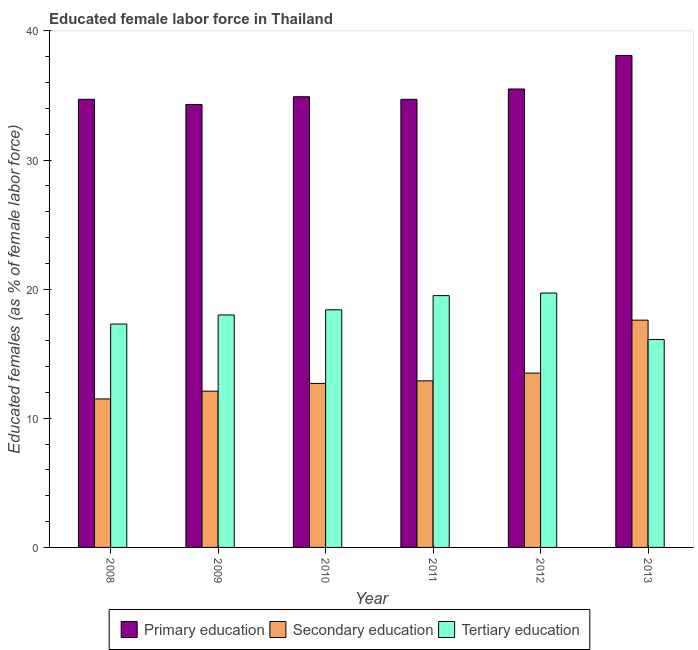Are the number of bars per tick equal to the number of legend labels?
Keep it short and to the point. Yes. Are the number of bars on each tick of the X-axis equal?
Provide a succinct answer. Yes. How many bars are there on the 1st tick from the right?
Your answer should be compact. 3. What is the percentage of female labor force who received primary education in 2011?
Your response must be concise. 34.7. Across all years, what is the maximum percentage of female labor force who received tertiary education?
Your response must be concise. 19.7. Across all years, what is the minimum percentage of female labor force who received secondary education?
Provide a succinct answer. 11.5. In which year was the percentage of female labor force who received tertiary education maximum?
Give a very brief answer. 2012. In which year was the percentage of female labor force who received secondary education minimum?
Ensure brevity in your answer.  2008. What is the total percentage of female labor force who received primary education in the graph?
Keep it short and to the point. 212.2. What is the difference between the percentage of female labor force who received tertiary education in 2010 and that in 2013?
Make the answer very short. 2.3. What is the difference between the percentage of female labor force who received secondary education in 2013 and the percentage of female labor force who received primary education in 2008?
Keep it short and to the point. 6.1. What is the average percentage of female labor force who received secondary education per year?
Ensure brevity in your answer.  13.38. In the year 2012, what is the difference between the percentage of female labor force who received tertiary education and percentage of female labor force who received secondary education?
Give a very brief answer. 0. What is the ratio of the percentage of female labor force who received secondary education in 2008 to that in 2010?
Make the answer very short. 0.91. What is the difference between the highest and the second highest percentage of female labor force who received secondary education?
Your answer should be compact. 4.1. What is the difference between the highest and the lowest percentage of female labor force who received primary education?
Ensure brevity in your answer.  3.8. In how many years, is the percentage of female labor force who received tertiary education greater than the average percentage of female labor force who received tertiary education taken over all years?
Make the answer very short. 3. What does the 3rd bar from the left in 2008 represents?
Provide a short and direct response. Tertiary education. Is it the case that in every year, the sum of the percentage of female labor force who received primary education and percentage of female labor force who received secondary education is greater than the percentage of female labor force who received tertiary education?
Provide a succinct answer. Yes. Does the graph contain any zero values?
Keep it short and to the point. No. Does the graph contain grids?
Ensure brevity in your answer.  No. How many legend labels are there?
Keep it short and to the point. 3. What is the title of the graph?
Ensure brevity in your answer.  Educated female labor force in Thailand. Does "Labor Market" appear as one of the legend labels in the graph?
Make the answer very short. No. What is the label or title of the X-axis?
Offer a terse response. Year. What is the label or title of the Y-axis?
Provide a short and direct response. Educated females (as % of female labor force). What is the Educated females (as % of female labor force) in Primary education in 2008?
Offer a terse response. 34.7. What is the Educated females (as % of female labor force) in Secondary education in 2008?
Your response must be concise. 11.5. What is the Educated females (as % of female labor force) in Tertiary education in 2008?
Offer a terse response. 17.3. What is the Educated females (as % of female labor force) in Primary education in 2009?
Your answer should be compact. 34.3. What is the Educated females (as % of female labor force) in Secondary education in 2009?
Provide a short and direct response. 12.1. What is the Educated females (as % of female labor force) in Primary education in 2010?
Make the answer very short. 34.9. What is the Educated females (as % of female labor force) of Secondary education in 2010?
Offer a very short reply. 12.7. What is the Educated females (as % of female labor force) in Tertiary education in 2010?
Offer a very short reply. 18.4. What is the Educated females (as % of female labor force) of Primary education in 2011?
Your answer should be compact. 34.7. What is the Educated females (as % of female labor force) of Secondary education in 2011?
Your answer should be compact. 12.9. What is the Educated females (as % of female labor force) of Tertiary education in 2011?
Offer a very short reply. 19.5. What is the Educated females (as % of female labor force) in Primary education in 2012?
Offer a very short reply. 35.5. What is the Educated females (as % of female labor force) of Tertiary education in 2012?
Your answer should be compact. 19.7. What is the Educated females (as % of female labor force) of Primary education in 2013?
Your response must be concise. 38.1. What is the Educated females (as % of female labor force) of Secondary education in 2013?
Offer a very short reply. 17.6. What is the Educated females (as % of female labor force) in Tertiary education in 2013?
Your answer should be compact. 16.1. Across all years, what is the maximum Educated females (as % of female labor force) of Primary education?
Give a very brief answer. 38.1. Across all years, what is the maximum Educated females (as % of female labor force) in Secondary education?
Provide a short and direct response. 17.6. Across all years, what is the maximum Educated females (as % of female labor force) of Tertiary education?
Offer a terse response. 19.7. Across all years, what is the minimum Educated females (as % of female labor force) of Primary education?
Provide a short and direct response. 34.3. Across all years, what is the minimum Educated females (as % of female labor force) of Secondary education?
Your answer should be compact. 11.5. Across all years, what is the minimum Educated females (as % of female labor force) in Tertiary education?
Your answer should be compact. 16.1. What is the total Educated females (as % of female labor force) in Primary education in the graph?
Your answer should be compact. 212.2. What is the total Educated females (as % of female labor force) of Secondary education in the graph?
Offer a very short reply. 80.3. What is the total Educated females (as % of female labor force) of Tertiary education in the graph?
Offer a very short reply. 109. What is the difference between the Educated females (as % of female labor force) in Secondary education in 2008 and that in 2009?
Offer a terse response. -0.6. What is the difference between the Educated females (as % of female labor force) in Primary education in 2008 and that in 2010?
Offer a very short reply. -0.2. What is the difference between the Educated females (as % of female labor force) of Tertiary education in 2008 and that in 2010?
Keep it short and to the point. -1.1. What is the difference between the Educated females (as % of female labor force) of Primary education in 2008 and that in 2011?
Provide a short and direct response. 0. What is the difference between the Educated females (as % of female labor force) of Tertiary education in 2008 and that in 2011?
Make the answer very short. -2.2. What is the difference between the Educated females (as % of female labor force) in Primary education in 2008 and that in 2012?
Provide a short and direct response. -0.8. What is the difference between the Educated females (as % of female labor force) of Tertiary education in 2008 and that in 2012?
Give a very brief answer. -2.4. What is the difference between the Educated females (as % of female labor force) of Primary education in 2008 and that in 2013?
Your answer should be compact. -3.4. What is the difference between the Educated females (as % of female labor force) of Secondary education in 2008 and that in 2013?
Give a very brief answer. -6.1. What is the difference between the Educated females (as % of female labor force) of Primary education in 2009 and that in 2010?
Make the answer very short. -0.6. What is the difference between the Educated females (as % of female labor force) in Primary education in 2009 and that in 2011?
Your answer should be very brief. -0.4. What is the difference between the Educated females (as % of female labor force) in Tertiary education in 2009 and that in 2011?
Provide a succinct answer. -1.5. What is the difference between the Educated females (as % of female labor force) of Primary education in 2009 and that in 2012?
Offer a very short reply. -1.2. What is the difference between the Educated females (as % of female labor force) in Secondary education in 2009 and that in 2012?
Your answer should be very brief. -1.4. What is the difference between the Educated females (as % of female labor force) in Primary education in 2009 and that in 2013?
Provide a short and direct response. -3.8. What is the difference between the Educated females (as % of female labor force) in Tertiary education in 2009 and that in 2013?
Your response must be concise. 1.9. What is the difference between the Educated females (as % of female labor force) of Primary education in 2010 and that in 2011?
Provide a succinct answer. 0.2. What is the difference between the Educated females (as % of female labor force) in Tertiary education in 2010 and that in 2012?
Keep it short and to the point. -1.3. What is the difference between the Educated females (as % of female labor force) of Secondary education in 2010 and that in 2013?
Your response must be concise. -4.9. What is the difference between the Educated females (as % of female labor force) in Tertiary education in 2010 and that in 2013?
Your response must be concise. 2.3. What is the difference between the Educated females (as % of female labor force) of Secondary education in 2011 and that in 2012?
Make the answer very short. -0.6. What is the difference between the Educated females (as % of female labor force) in Secondary education in 2011 and that in 2013?
Ensure brevity in your answer.  -4.7. What is the difference between the Educated females (as % of female labor force) in Secondary education in 2012 and that in 2013?
Provide a succinct answer. -4.1. What is the difference between the Educated females (as % of female labor force) in Tertiary education in 2012 and that in 2013?
Your answer should be very brief. 3.6. What is the difference between the Educated females (as % of female labor force) of Primary education in 2008 and the Educated females (as % of female labor force) of Secondary education in 2009?
Give a very brief answer. 22.6. What is the difference between the Educated females (as % of female labor force) in Secondary education in 2008 and the Educated females (as % of female labor force) in Tertiary education in 2009?
Provide a succinct answer. -6.5. What is the difference between the Educated females (as % of female labor force) of Primary education in 2008 and the Educated females (as % of female labor force) of Tertiary education in 2010?
Give a very brief answer. 16.3. What is the difference between the Educated females (as % of female labor force) in Secondary education in 2008 and the Educated females (as % of female labor force) in Tertiary education in 2010?
Your answer should be very brief. -6.9. What is the difference between the Educated females (as % of female labor force) of Primary education in 2008 and the Educated females (as % of female labor force) of Secondary education in 2011?
Keep it short and to the point. 21.8. What is the difference between the Educated females (as % of female labor force) of Primary education in 2008 and the Educated females (as % of female labor force) of Tertiary education in 2011?
Provide a succinct answer. 15.2. What is the difference between the Educated females (as % of female labor force) of Secondary education in 2008 and the Educated females (as % of female labor force) of Tertiary education in 2011?
Your answer should be very brief. -8. What is the difference between the Educated females (as % of female labor force) of Primary education in 2008 and the Educated females (as % of female labor force) of Secondary education in 2012?
Offer a very short reply. 21.2. What is the difference between the Educated females (as % of female labor force) of Primary education in 2008 and the Educated females (as % of female labor force) of Tertiary education in 2012?
Offer a terse response. 15. What is the difference between the Educated females (as % of female labor force) in Secondary education in 2008 and the Educated females (as % of female labor force) in Tertiary education in 2012?
Keep it short and to the point. -8.2. What is the difference between the Educated females (as % of female labor force) of Primary education in 2008 and the Educated females (as % of female labor force) of Tertiary education in 2013?
Give a very brief answer. 18.6. What is the difference between the Educated females (as % of female labor force) in Secondary education in 2008 and the Educated females (as % of female labor force) in Tertiary education in 2013?
Offer a very short reply. -4.6. What is the difference between the Educated females (as % of female labor force) in Primary education in 2009 and the Educated females (as % of female labor force) in Secondary education in 2010?
Offer a very short reply. 21.6. What is the difference between the Educated females (as % of female labor force) in Primary education in 2009 and the Educated females (as % of female labor force) in Tertiary education in 2010?
Keep it short and to the point. 15.9. What is the difference between the Educated females (as % of female labor force) in Secondary education in 2009 and the Educated females (as % of female labor force) in Tertiary education in 2010?
Offer a very short reply. -6.3. What is the difference between the Educated females (as % of female labor force) of Primary education in 2009 and the Educated females (as % of female labor force) of Secondary education in 2011?
Give a very brief answer. 21.4. What is the difference between the Educated females (as % of female labor force) of Secondary education in 2009 and the Educated females (as % of female labor force) of Tertiary education in 2011?
Give a very brief answer. -7.4. What is the difference between the Educated females (as % of female labor force) of Primary education in 2009 and the Educated females (as % of female labor force) of Secondary education in 2012?
Your answer should be very brief. 20.8. What is the difference between the Educated females (as % of female labor force) of Primary education in 2009 and the Educated females (as % of female labor force) of Tertiary education in 2012?
Your answer should be very brief. 14.6. What is the difference between the Educated females (as % of female labor force) in Primary education in 2009 and the Educated females (as % of female labor force) in Secondary education in 2013?
Provide a succinct answer. 16.7. What is the difference between the Educated females (as % of female labor force) of Primary education in 2009 and the Educated females (as % of female labor force) of Tertiary education in 2013?
Your response must be concise. 18.2. What is the difference between the Educated females (as % of female labor force) in Primary education in 2010 and the Educated females (as % of female labor force) in Secondary education in 2011?
Your response must be concise. 22. What is the difference between the Educated females (as % of female labor force) in Secondary education in 2010 and the Educated females (as % of female labor force) in Tertiary education in 2011?
Keep it short and to the point. -6.8. What is the difference between the Educated females (as % of female labor force) of Primary education in 2010 and the Educated females (as % of female labor force) of Secondary education in 2012?
Make the answer very short. 21.4. What is the difference between the Educated females (as % of female labor force) of Primary education in 2010 and the Educated females (as % of female labor force) of Tertiary education in 2012?
Offer a terse response. 15.2. What is the difference between the Educated females (as % of female labor force) of Primary education in 2010 and the Educated females (as % of female labor force) of Secondary education in 2013?
Give a very brief answer. 17.3. What is the difference between the Educated females (as % of female labor force) in Primary education in 2010 and the Educated females (as % of female labor force) in Tertiary education in 2013?
Ensure brevity in your answer.  18.8. What is the difference between the Educated females (as % of female labor force) in Secondary education in 2010 and the Educated females (as % of female labor force) in Tertiary education in 2013?
Offer a terse response. -3.4. What is the difference between the Educated females (as % of female labor force) of Primary education in 2011 and the Educated females (as % of female labor force) of Secondary education in 2012?
Your answer should be very brief. 21.2. What is the difference between the Educated females (as % of female labor force) in Secondary education in 2011 and the Educated females (as % of female labor force) in Tertiary education in 2012?
Ensure brevity in your answer.  -6.8. What is the difference between the Educated females (as % of female labor force) in Primary education in 2011 and the Educated females (as % of female labor force) in Secondary education in 2013?
Ensure brevity in your answer.  17.1. What is the difference between the Educated females (as % of female labor force) in Primary education in 2011 and the Educated females (as % of female labor force) in Tertiary education in 2013?
Your response must be concise. 18.6. What is the difference between the Educated females (as % of female labor force) in Secondary education in 2012 and the Educated females (as % of female labor force) in Tertiary education in 2013?
Your response must be concise. -2.6. What is the average Educated females (as % of female labor force) in Primary education per year?
Your answer should be very brief. 35.37. What is the average Educated females (as % of female labor force) of Secondary education per year?
Keep it short and to the point. 13.38. What is the average Educated females (as % of female labor force) in Tertiary education per year?
Provide a short and direct response. 18.17. In the year 2008, what is the difference between the Educated females (as % of female labor force) in Primary education and Educated females (as % of female labor force) in Secondary education?
Offer a very short reply. 23.2. In the year 2008, what is the difference between the Educated females (as % of female labor force) in Primary education and Educated females (as % of female labor force) in Tertiary education?
Your response must be concise. 17.4. In the year 2008, what is the difference between the Educated females (as % of female labor force) in Secondary education and Educated females (as % of female labor force) in Tertiary education?
Your answer should be very brief. -5.8. In the year 2009, what is the difference between the Educated females (as % of female labor force) in Primary education and Educated females (as % of female labor force) in Secondary education?
Your answer should be very brief. 22.2. In the year 2010, what is the difference between the Educated females (as % of female labor force) of Primary education and Educated females (as % of female labor force) of Secondary education?
Your answer should be compact. 22.2. In the year 2010, what is the difference between the Educated females (as % of female labor force) in Primary education and Educated females (as % of female labor force) in Tertiary education?
Provide a succinct answer. 16.5. In the year 2011, what is the difference between the Educated females (as % of female labor force) of Primary education and Educated females (as % of female labor force) of Secondary education?
Provide a succinct answer. 21.8. In the year 2011, what is the difference between the Educated females (as % of female labor force) in Secondary education and Educated females (as % of female labor force) in Tertiary education?
Keep it short and to the point. -6.6. In the year 2012, what is the difference between the Educated females (as % of female labor force) in Primary education and Educated females (as % of female labor force) in Tertiary education?
Your answer should be very brief. 15.8. In the year 2013, what is the difference between the Educated females (as % of female labor force) of Primary education and Educated females (as % of female labor force) of Tertiary education?
Your answer should be compact. 22. In the year 2013, what is the difference between the Educated females (as % of female labor force) of Secondary education and Educated females (as % of female labor force) of Tertiary education?
Ensure brevity in your answer.  1.5. What is the ratio of the Educated females (as % of female labor force) of Primary education in 2008 to that in 2009?
Keep it short and to the point. 1.01. What is the ratio of the Educated females (as % of female labor force) of Secondary education in 2008 to that in 2009?
Provide a short and direct response. 0.95. What is the ratio of the Educated females (as % of female labor force) in Tertiary education in 2008 to that in 2009?
Ensure brevity in your answer.  0.96. What is the ratio of the Educated females (as % of female labor force) in Secondary education in 2008 to that in 2010?
Your answer should be compact. 0.91. What is the ratio of the Educated females (as % of female labor force) in Tertiary education in 2008 to that in 2010?
Your response must be concise. 0.94. What is the ratio of the Educated females (as % of female labor force) of Primary education in 2008 to that in 2011?
Provide a succinct answer. 1. What is the ratio of the Educated females (as % of female labor force) in Secondary education in 2008 to that in 2011?
Your answer should be very brief. 0.89. What is the ratio of the Educated females (as % of female labor force) in Tertiary education in 2008 to that in 2011?
Ensure brevity in your answer.  0.89. What is the ratio of the Educated females (as % of female labor force) in Primary education in 2008 to that in 2012?
Keep it short and to the point. 0.98. What is the ratio of the Educated females (as % of female labor force) of Secondary education in 2008 to that in 2012?
Keep it short and to the point. 0.85. What is the ratio of the Educated females (as % of female labor force) of Tertiary education in 2008 to that in 2012?
Give a very brief answer. 0.88. What is the ratio of the Educated females (as % of female labor force) of Primary education in 2008 to that in 2013?
Offer a terse response. 0.91. What is the ratio of the Educated females (as % of female labor force) in Secondary education in 2008 to that in 2013?
Your response must be concise. 0.65. What is the ratio of the Educated females (as % of female labor force) of Tertiary education in 2008 to that in 2013?
Your response must be concise. 1.07. What is the ratio of the Educated females (as % of female labor force) of Primary education in 2009 to that in 2010?
Give a very brief answer. 0.98. What is the ratio of the Educated females (as % of female labor force) in Secondary education in 2009 to that in 2010?
Your response must be concise. 0.95. What is the ratio of the Educated females (as % of female labor force) of Tertiary education in 2009 to that in 2010?
Offer a terse response. 0.98. What is the ratio of the Educated females (as % of female labor force) in Secondary education in 2009 to that in 2011?
Keep it short and to the point. 0.94. What is the ratio of the Educated females (as % of female labor force) in Tertiary education in 2009 to that in 2011?
Your response must be concise. 0.92. What is the ratio of the Educated females (as % of female labor force) in Primary education in 2009 to that in 2012?
Provide a succinct answer. 0.97. What is the ratio of the Educated females (as % of female labor force) in Secondary education in 2009 to that in 2012?
Your response must be concise. 0.9. What is the ratio of the Educated females (as % of female labor force) in Tertiary education in 2009 to that in 2012?
Keep it short and to the point. 0.91. What is the ratio of the Educated females (as % of female labor force) of Primary education in 2009 to that in 2013?
Offer a very short reply. 0.9. What is the ratio of the Educated females (as % of female labor force) of Secondary education in 2009 to that in 2013?
Make the answer very short. 0.69. What is the ratio of the Educated females (as % of female labor force) of Tertiary education in 2009 to that in 2013?
Provide a short and direct response. 1.12. What is the ratio of the Educated females (as % of female labor force) of Secondary education in 2010 to that in 2011?
Your answer should be compact. 0.98. What is the ratio of the Educated females (as % of female labor force) in Tertiary education in 2010 to that in 2011?
Keep it short and to the point. 0.94. What is the ratio of the Educated females (as % of female labor force) of Primary education in 2010 to that in 2012?
Keep it short and to the point. 0.98. What is the ratio of the Educated females (as % of female labor force) in Secondary education in 2010 to that in 2012?
Make the answer very short. 0.94. What is the ratio of the Educated females (as % of female labor force) in Tertiary education in 2010 to that in 2012?
Your answer should be very brief. 0.93. What is the ratio of the Educated females (as % of female labor force) of Primary education in 2010 to that in 2013?
Your response must be concise. 0.92. What is the ratio of the Educated females (as % of female labor force) of Secondary education in 2010 to that in 2013?
Ensure brevity in your answer.  0.72. What is the ratio of the Educated females (as % of female labor force) of Primary education in 2011 to that in 2012?
Offer a very short reply. 0.98. What is the ratio of the Educated females (as % of female labor force) of Secondary education in 2011 to that in 2012?
Ensure brevity in your answer.  0.96. What is the ratio of the Educated females (as % of female labor force) in Primary education in 2011 to that in 2013?
Provide a short and direct response. 0.91. What is the ratio of the Educated females (as % of female labor force) in Secondary education in 2011 to that in 2013?
Provide a short and direct response. 0.73. What is the ratio of the Educated females (as % of female labor force) of Tertiary education in 2011 to that in 2013?
Provide a succinct answer. 1.21. What is the ratio of the Educated females (as % of female labor force) of Primary education in 2012 to that in 2013?
Your response must be concise. 0.93. What is the ratio of the Educated females (as % of female labor force) of Secondary education in 2012 to that in 2013?
Make the answer very short. 0.77. What is the ratio of the Educated females (as % of female labor force) of Tertiary education in 2012 to that in 2013?
Offer a terse response. 1.22. What is the difference between the highest and the lowest Educated females (as % of female labor force) in Tertiary education?
Your answer should be very brief. 3.6. 